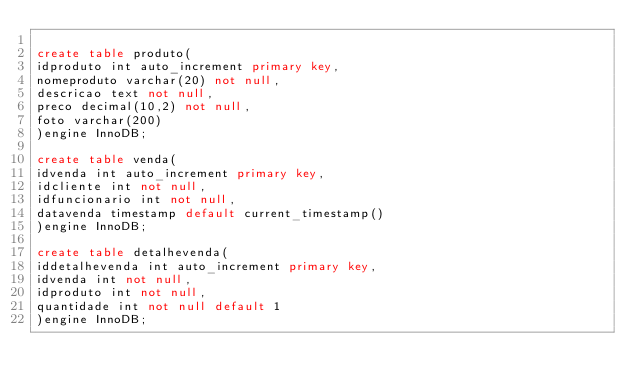Convert code to text. <code><loc_0><loc_0><loc_500><loc_500><_SQL_>
create table produto(
idproduto int auto_increment primary key,
nomeproduto varchar(20) not null,
descricao text not null,
preco decimal(10,2) not null,
foto varchar(200)
)engine InnoDB;

create table venda(
idvenda int auto_increment primary key,
idcliente int not null,
idfuncionario int not null,
datavenda timestamp default current_timestamp()
)engine InnoDB;

create table detalhevenda(
iddetalhevenda int auto_increment primary key,
idvenda int not null,
idproduto int not null,
quantidade int not null default 1
)engine InnoDB;</code> 